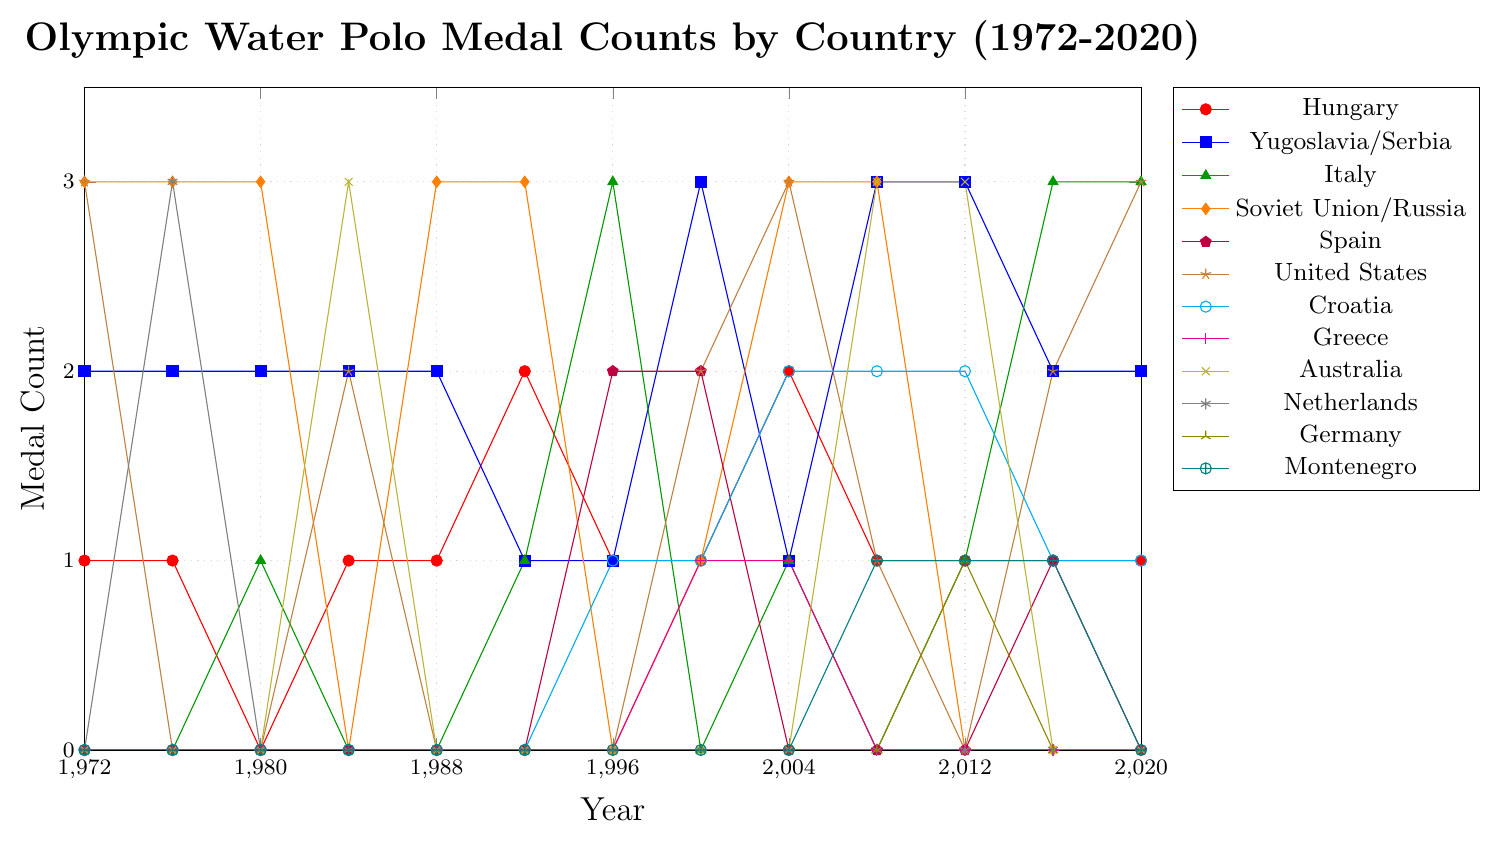Which country has the highest number of medals in the 2000 Olympics? By looking at the data for the year 2000 on the plot, we can find which country has the highest point vertically.
In the 2000 Olympics, Yugoslavia/Serbia has the highest medal count with 3 medals.
Answer: Yugoslavia/Serbia Which country shows a consistent medal-winning performance over the years? By examining the trend lines of the countries, we can check which country's line shows medals in multiple years without dropping to zero too frequently.
Hungary has a consistently high medal count over the years.
Answer: Hungary What is the total medal count for Italy from 1972 to 2020? We need to sum Italy's medal count for each year from 1972 to 2020.
Adding Italy's medals: 0+0+1+0+0+1+3+0+1+0+1+3+3, the total is 13.
Answer: 13 In which years did the Soviet Union/Russia win 3 medals? We look at the vertical positions of the markers along the Soviet Union/Russia line to determine the years where they reach a height of 3.
Soviet Union/Russia won 3 medals in 1972, 1976, 1980, 1988, 1992, 2004, and 2008.
Answer: 1972, 1976, 1980, 1988, 1992, 2004, 2008 Which years did Germany win a medal? We check Germany’s line and identify the years where the line is above zero.
Germany won a medal in 2012 only.
Answer: 2012 How many times has Spain won more than one medal in a single Olympics? We count the number of times the data points for Spain are 2 or more.
Spain won more than one medal in 1996 and 2000, totaling 2 times.
Answer: 2 Which country had the biggest drop in medal counts between two consecutive Olympics? Identify the country with the highest difference between medals won in two consecutive years.
Soviet Union/Russia had the biggest drop from 3 medals in 1980 to 0 medals in 1984. The drop is 3 medals.
Answer: Soviet Union/Russia Compare the medal counts of the United States and Croatia in the 2008 Olympics. Which country won more medals and how many more? Look at the marker positions for the United States and Croatia in 2008 and compare their heights to determine which is higher.
In 2008, Croatia won 2 medals while the United States won 1 medal. Croatia won 1 more medal than the United States.
Answer: Croatia, 1 more What's the average medal count for Hungary over the entire period shown in the chart? Calculate the sum of Hungary’s medals and divide by the total number of observed years.
Adding Hungary's medals: 1+1+0+1+1+2+1+1+2+1+1+1+1. The sum is 14. There are 13 Olympics, so the average is 14/13 ≈ 1.08.
Answer: 1.08 Which country showed an increase in medal counts from 2012 to 2016 but then dropped in 2020? We look at the line trends for each country between 2012, 2016, and 2020.
United States had an increase from 0 medals in 2012 to 2 in 2016, then later dropped to 3 in 2020.
Answer: United States 